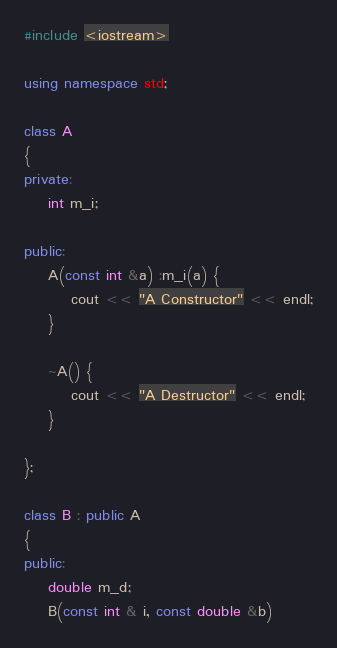Convert code to text. <code><loc_0><loc_0><loc_500><loc_500><_C++_>#include <iostream>

using namespace std;

class A
{
private:
	int m_i;

public:
	A(const int &a) :m_i(a) {
		cout << "A Constructor" << endl;
	}

	~A() {
		cout << "A Destructor" << endl;
	}

};

class B : public A
{
public:
	double m_d;
	B(const int & i, const double &b)</code> 